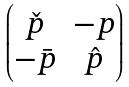Convert formula to latex. <formula><loc_0><loc_0><loc_500><loc_500>\begin{pmatrix} \check { p } & - p \\ - \bar { p } & \hat { p } \end{pmatrix}</formula> 